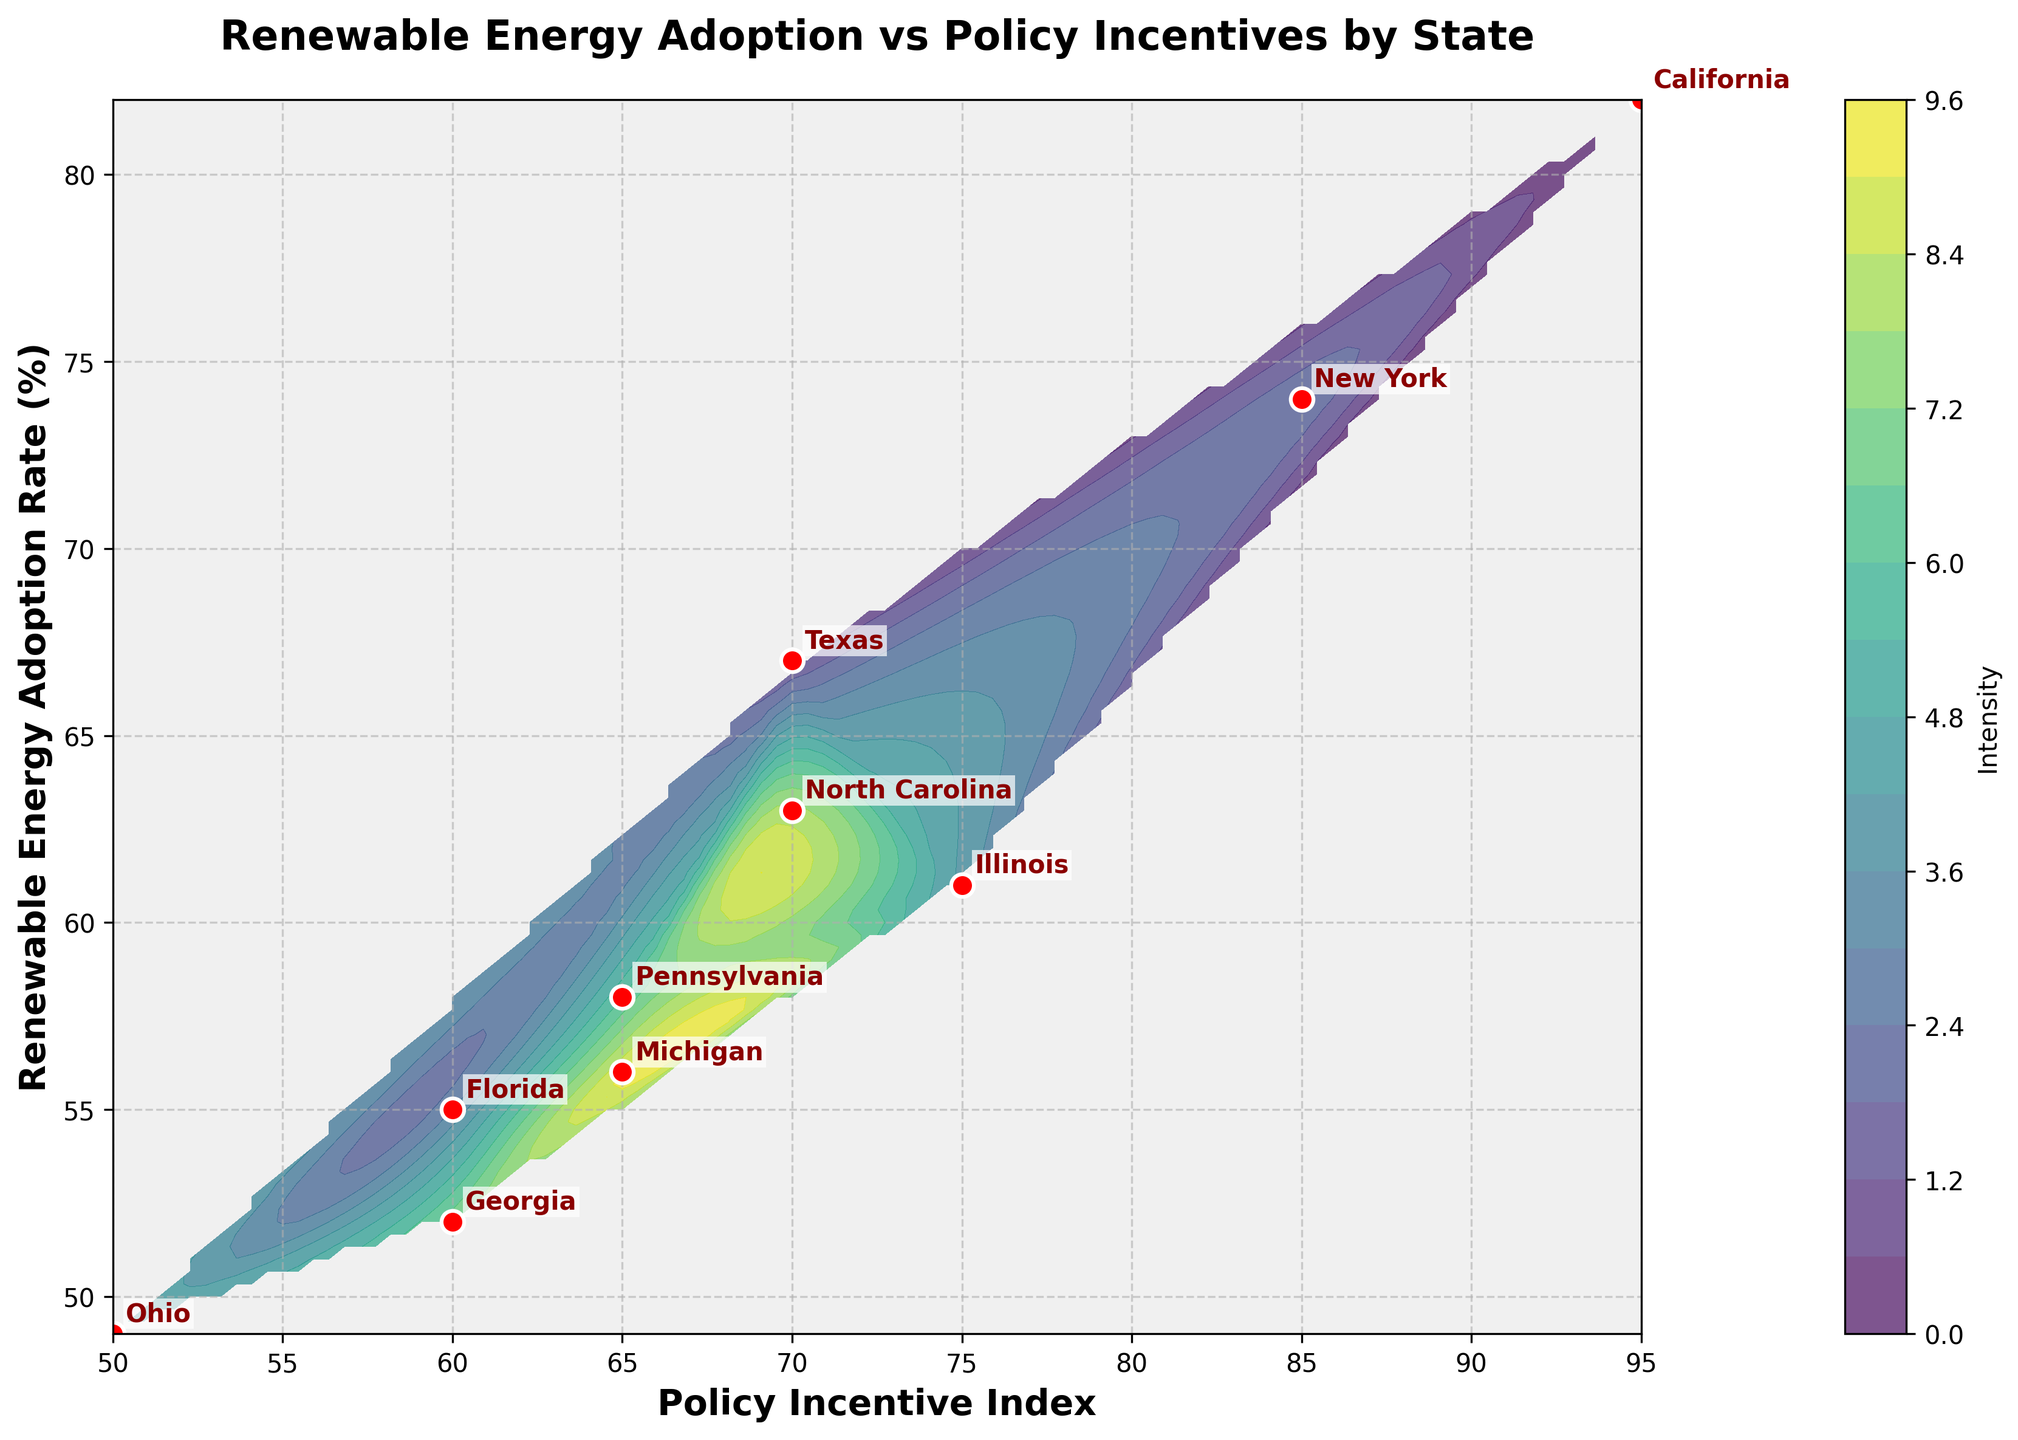What is the title of the plot? The title of the plot is located at the top and usually describes the subject of the data visualization. Here it reads "Renewable Energy Adoption vs Policy Incentives by State".
Answer: Renewable Energy Adoption vs Policy Incentives by State What do the x-axis and y-axis represent? The x-axis represents the Policy Incentive Index, while the y-axis represents the Renewable Energy Adoption Rate (%). This is indicated by the axis labels.
Answer: Policy Incentive Index and Renewable Energy Adoption Rate (%) How many states are represented in the plot? Each red dot in the plot represents a state, and there are labeled annotations for each state’s data point. Counting these labels gives the number of states. There are 10 states represented.
Answer: 10 Which state has the highest Renewable Energy Adoption Rate? Find the highest point on the y-axis, which represents the Renewable Energy Adoption Rate (%). The state at this point is labeled. The highest Renewable Energy Adoption Rate is 82%, which belongs to California.
Answer: California Which state has the lowest Policy Incentive Index? Locate the leftmost point on the x-axis, which represents the Policy Incentive Index. The state at this point is labeled. The lowest Policy Incentive Index is 50, which belongs to Ohio.
Answer: Ohio Which state has the closest Adoption Rate to 60% and what is its Policy Incentive Index? Identify the point on the y-axis closest to 60%, then check the corresponding label for that data point to find the state. The state is Florida with an Adoption Rate of 55% and a Policy Incentive Index of 60.
Answer: Florida, 60 Is there a visible correlation between Policy Incentive Index and Renewable Energy Adoption Rate? Analyze the overall trend of the data points in the scatter plot. A positive correlation would show an upward trend from left to right, while a negative correlation would show a downward trend. The plot shows a positive correlation where higher Policy Incentive Index generally corresponds with higher Renewable Energy Adoption Rates.
Answer: Yes, positive correlation Which state has a Policy Incentive Index of 70 and what is its Renewable Energy Adoption Rate? Locate the point on the x-axis at 70, then identify the corresponding point on the y-axis and check the label. Both Texas and North Carolina have a Policy Incentive Index of 70 with Renewable Energy Adoption Rates of 67% and 63%, respectively.
Answer: Texas (67%) and North Carolina (63%) What is the difference in Renewable Energy Adoption Rates between New York and North Carolina? Find the Renewable Energy Adoption Rates for New York and North Carolina from the plot (74% and 63%, respectively), and calculate the difference. 74% - 63% = 11%.
Answer: 11% Which states fall within the Policy Incentive Index range of 60-70? Identify all states with data points along the x-axis between 60 and 70 and check their labels. These states are Florida, Georgia, and Michigan.
Answer: Florida, Georgia, Michigan 